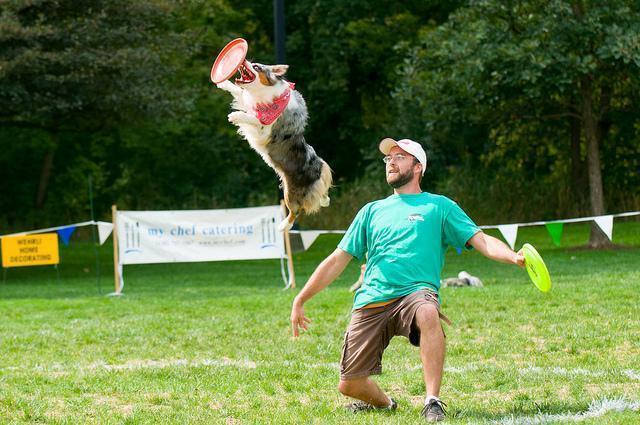What kind of service does the white sign promise?
Choose the right answer and clarify with the format: 'Answer: answer
Rationale: rationale.'
Options: Food prep, teeth cleaning, tanning, gardening. Answer: food prep.
Rationale: The white sign says my chef catering and offers foods for events. 